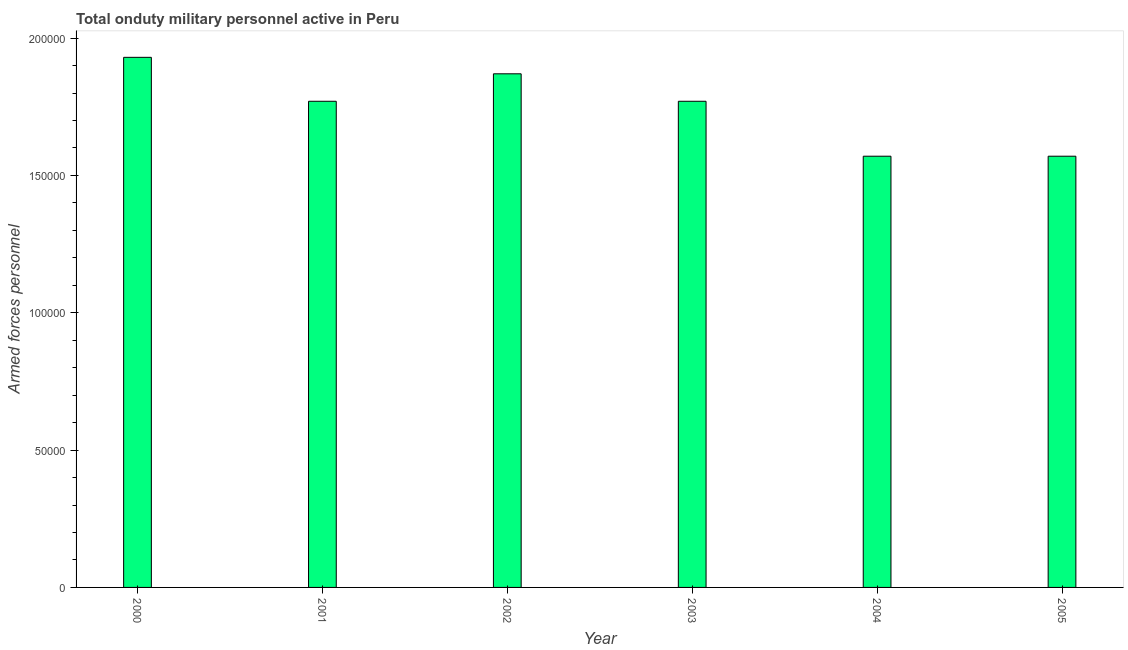Does the graph contain any zero values?
Ensure brevity in your answer.  No. What is the title of the graph?
Your response must be concise. Total onduty military personnel active in Peru. What is the label or title of the X-axis?
Ensure brevity in your answer.  Year. What is the label or title of the Y-axis?
Your answer should be compact. Armed forces personnel. What is the number of armed forces personnel in 2003?
Offer a very short reply. 1.77e+05. Across all years, what is the maximum number of armed forces personnel?
Offer a very short reply. 1.93e+05. Across all years, what is the minimum number of armed forces personnel?
Your response must be concise. 1.57e+05. What is the sum of the number of armed forces personnel?
Provide a short and direct response. 1.05e+06. What is the average number of armed forces personnel per year?
Provide a succinct answer. 1.75e+05. What is the median number of armed forces personnel?
Offer a very short reply. 1.77e+05. Do a majority of the years between 2002 and 2004 (inclusive) have number of armed forces personnel greater than 190000 ?
Your answer should be compact. No. What is the ratio of the number of armed forces personnel in 2002 to that in 2004?
Make the answer very short. 1.19. Is the difference between the number of armed forces personnel in 2001 and 2004 greater than the difference between any two years?
Keep it short and to the point. No. What is the difference between the highest and the second highest number of armed forces personnel?
Your answer should be very brief. 6000. What is the difference between the highest and the lowest number of armed forces personnel?
Provide a short and direct response. 3.60e+04. In how many years, is the number of armed forces personnel greater than the average number of armed forces personnel taken over all years?
Offer a terse response. 4. How many years are there in the graph?
Keep it short and to the point. 6. What is the difference between two consecutive major ticks on the Y-axis?
Make the answer very short. 5.00e+04. Are the values on the major ticks of Y-axis written in scientific E-notation?
Provide a succinct answer. No. What is the Armed forces personnel of 2000?
Your response must be concise. 1.93e+05. What is the Armed forces personnel of 2001?
Offer a terse response. 1.77e+05. What is the Armed forces personnel in 2002?
Give a very brief answer. 1.87e+05. What is the Armed forces personnel in 2003?
Your answer should be compact. 1.77e+05. What is the Armed forces personnel in 2004?
Keep it short and to the point. 1.57e+05. What is the Armed forces personnel of 2005?
Offer a terse response. 1.57e+05. What is the difference between the Armed forces personnel in 2000 and 2001?
Keep it short and to the point. 1.60e+04. What is the difference between the Armed forces personnel in 2000 and 2002?
Your answer should be very brief. 6000. What is the difference between the Armed forces personnel in 2000 and 2003?
Your answer should be very brief. 1.60e+04. What is the difference between the Armed forces personnel in 2000 and 2004?
Provide a succinct answer. 3.60e+04. What is the difference between the Armed forces personnel in 2000 and 2005?
Offer a very short reply. 3.60e+04. What is the difference between the Armed forces personnel in 2001 and 2002?
Keep it short and to the point. -10000. What is the difference between the Armed forces personnel in 2001 and 2004?
Provide a succinct answer. 2.00e+04. What is the difference between the Armed forces personnel in 2001 and 2005?
Your answer should be compact. 2.00e+04. What is the difference between the Armed forces personnel in 2002 and 2004?
Your response must be concise. 3.00e+04. What is the difference between the Armed forces personnel in 2003 and 2004?
Provide a succinct answer. 2.00e+04. What is the difference between the Armed forces personnel in 2003 and 2005?
Provide a succinct answer. 2.00e+04. What is the difference between the Armed forces personnel in 2004 and 2005?
Ensure brevity in your answer.  0. What is the ratio of the Armed forces personnel in 2000 to that in 2001?
Give a very brief answer. 1.09. What is the ratio of the Armed forces personnel in 2000 to that in 2002?
Offer a very short reply. 1.03. What is the ratio of the Armed forces personnel in 2000 to that in 2003?
Your answer should be compact. 1.09. What is the ratio of the Armed forces personnel in 2000 to that in 2004?
Ensure brevity in your answer.  1.23. What is the ratio of the Armed forces personnel in 2000 to that in 2005?
Keep it short and to the point. 1.23. What is the ratio of the Armed forces personnel in 2001 to that in 2002?
Offer a very short reply. 0.95. What is the ratio of the Armed forces personnel in 2001 to that in 2003?
Your answer should be compact. 1. What is the ratio of the Armed forces personnel in 2001 to that in 2004?
Provide a succinct answer. 1.13. What is the ratio of the Armed forces personnel in 2001 to that in 2005?
Your answer should be compact. 1.13. What is the ratio of the Armed forces personnel in 2002 to that in 2003?
Your answer should be very brief. 1.06. What is the ratio of the Armed forces personnel in 2002 to that in 2004?
Offer a terse response. 1.19. What is the ratio of the Armed forces personnel in 2002 to that in 2005?
Give a very brief answer. 1.19. What is the ratio of the Armed forces personnel in 2003 to that in 2004?
Offer a terse response. 1.13. What is the ratio of the Armed forces personnel in 2003 to that in 2005?
Your response must be concise. 1.13. What is the ratio of the Armed forces personnel in 2004 to that in 2005?
Ensure brevity in your answer.  1. 